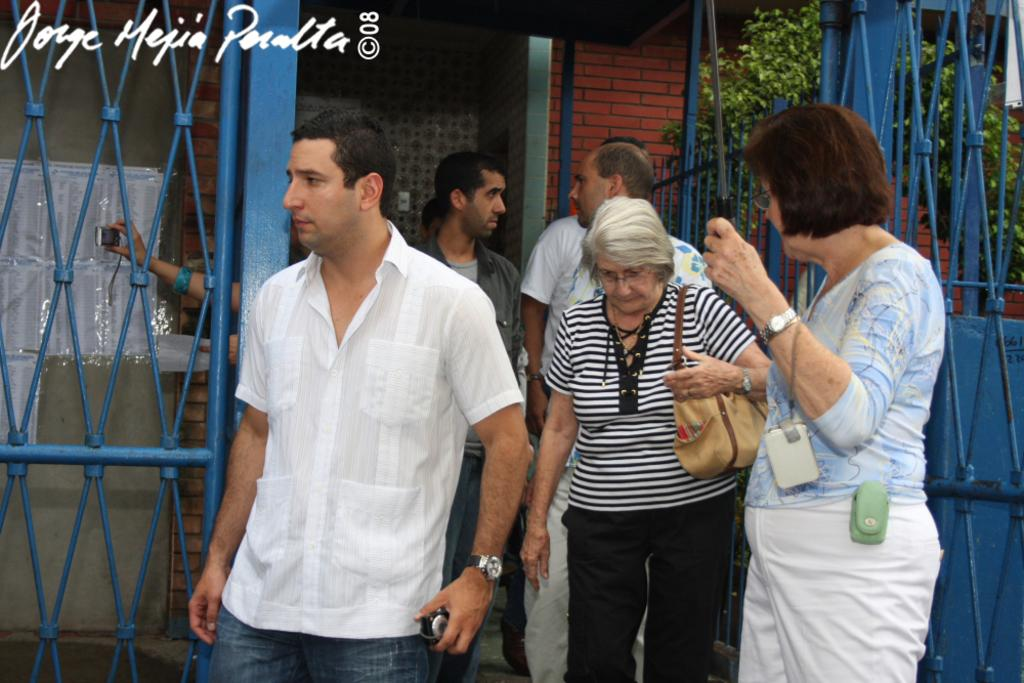Who is present in the image? There are old women and a man in the image. What are the people in the image doing? The man and women are walking. What can be seen in the background of the image? There is a blue iron grill and a brown brick wall in the image. What type of error can be seen in the image? There is no error present in the image. What is the man doing with his hand in the image? The man's hands are not visible in the image, so it cannot be determined what he is doing with them. 